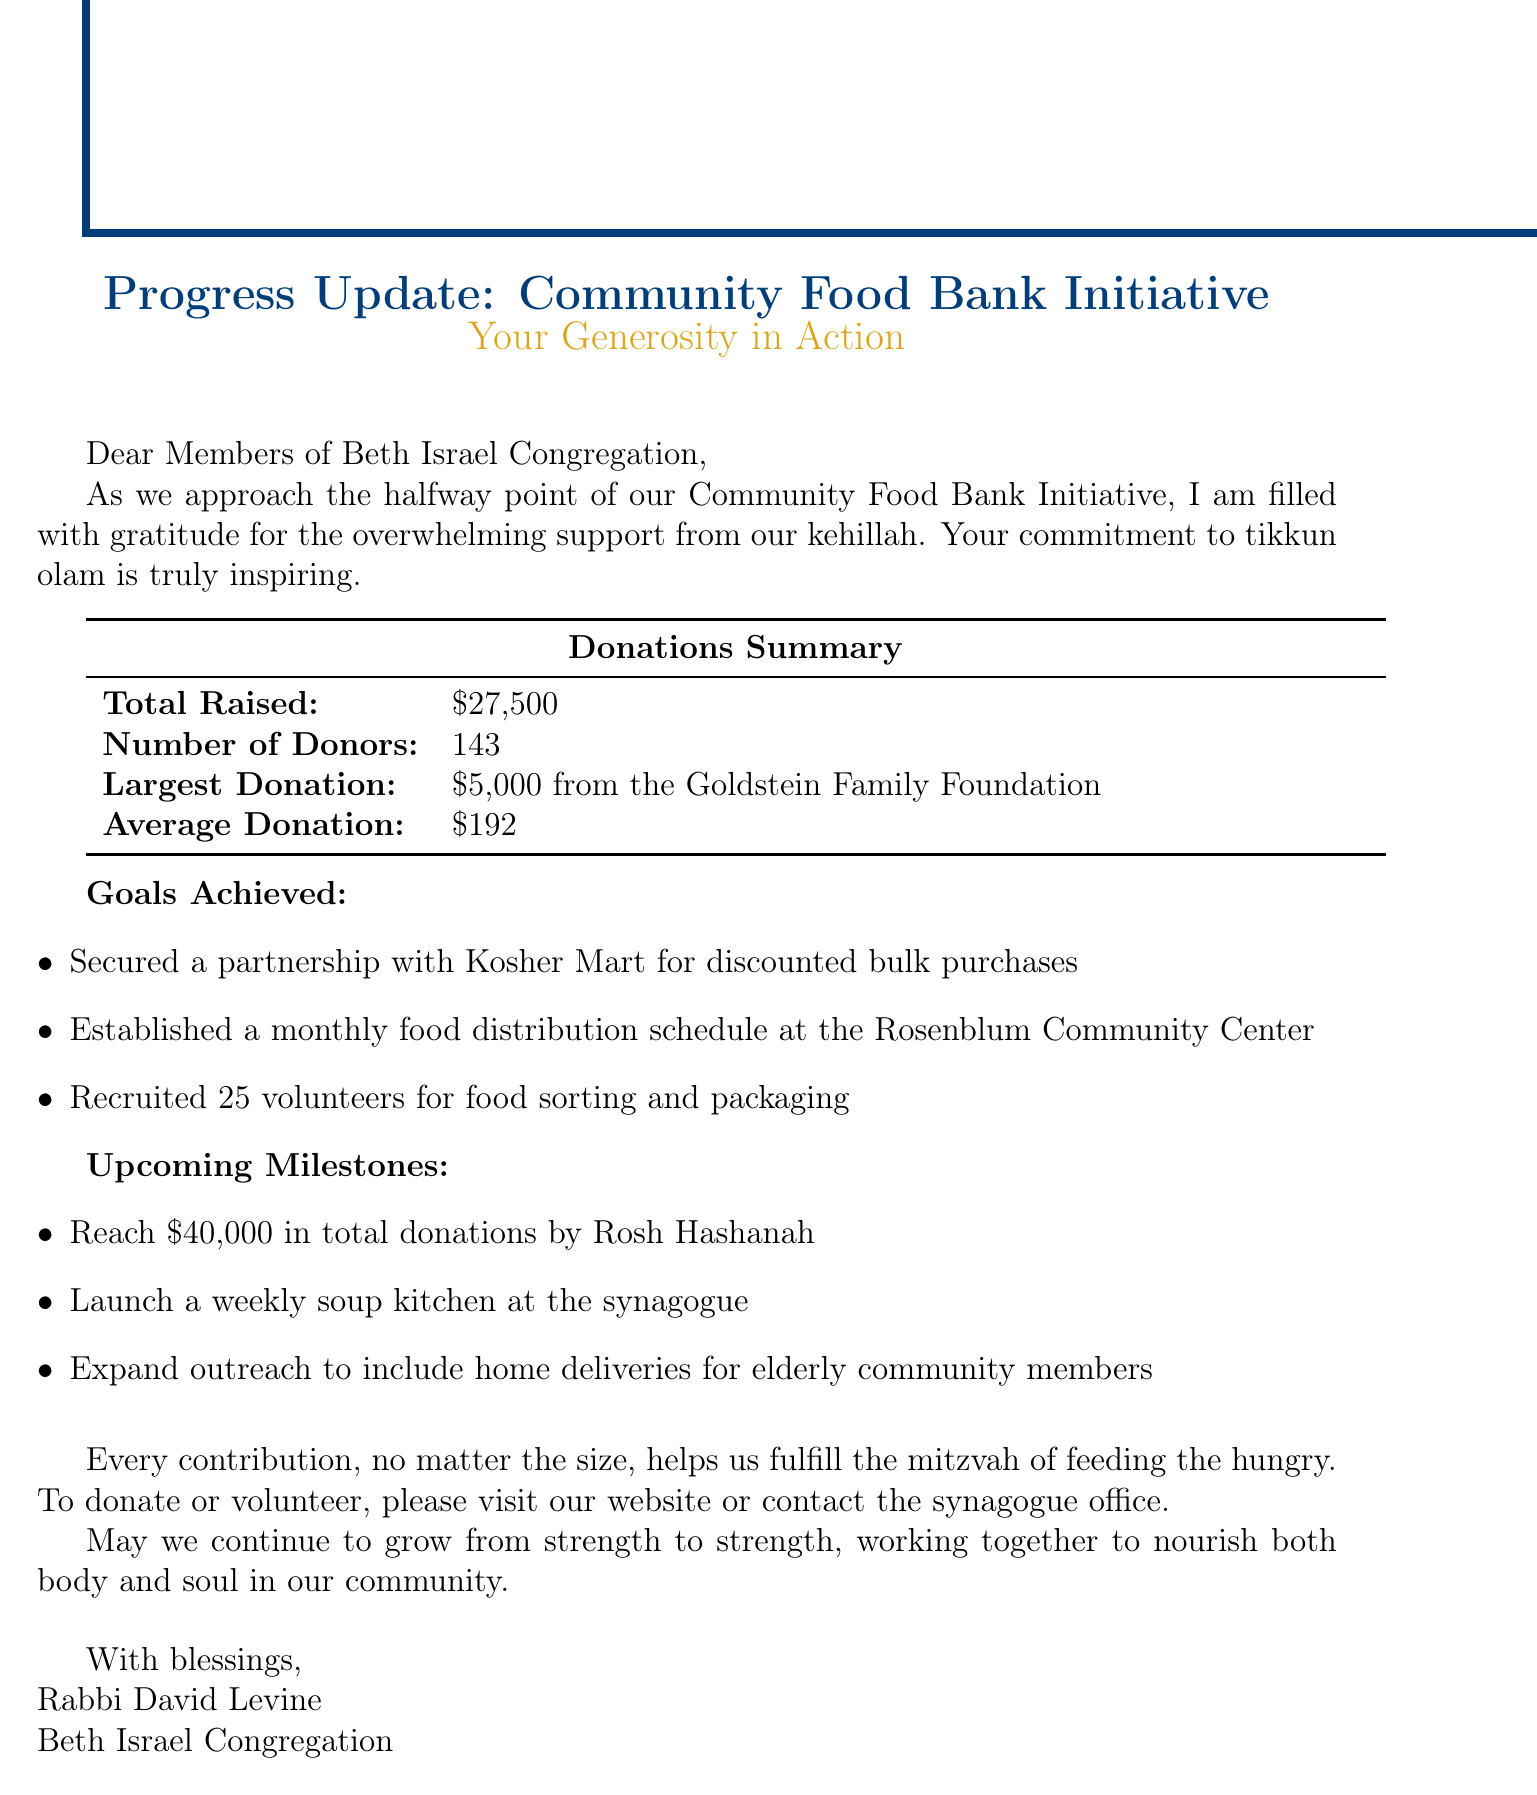What is the total amount raised? The total amount raised is specified in the donations summary of the document.
Answer: $27,500 How many donors contributed? The number of donors is listed in the donations summary section.
Answer: 143 What is the largest donation received? The largest donation is mentioned in the donations summary section along with the name of the donor.
Answer: $5,000 from the Goldstein Family Foundation What goal was achieved related to food distribution? One of the goals achieved mentions the establishment of a food distribution schedule.
Answer: Established a monthly food distribution schedule at the Rosenblum Community Center What is the upcoming milestone for fundraising? The document states a specific fundraising goal that needs to be achieved by Rosh Hashanah.
Answer: Reach $40,000 in total donations by Rosh Hashanah What important partnership was secured? The achieved goal mentions a partnership for bulk food purchases.
Answer: Partnership with Kosher Mart for discounted bulk purchases How many volunteers were recruited? The document mentions the number of volunteers in the goals achieved section.
Answer: 25 volunteers What call to action is given to the community? The document contains a specific invitation for how the community can contribute.
Answer: To donate or volunteer, please visit our website or contact the synagogue office What is the document's overall purpose? The document serves to update the congregation on the progress of the food bank initiative, showcasing achievements and encouraging further participation.
Answer: Progress Update: Community Food Bank Initiative 